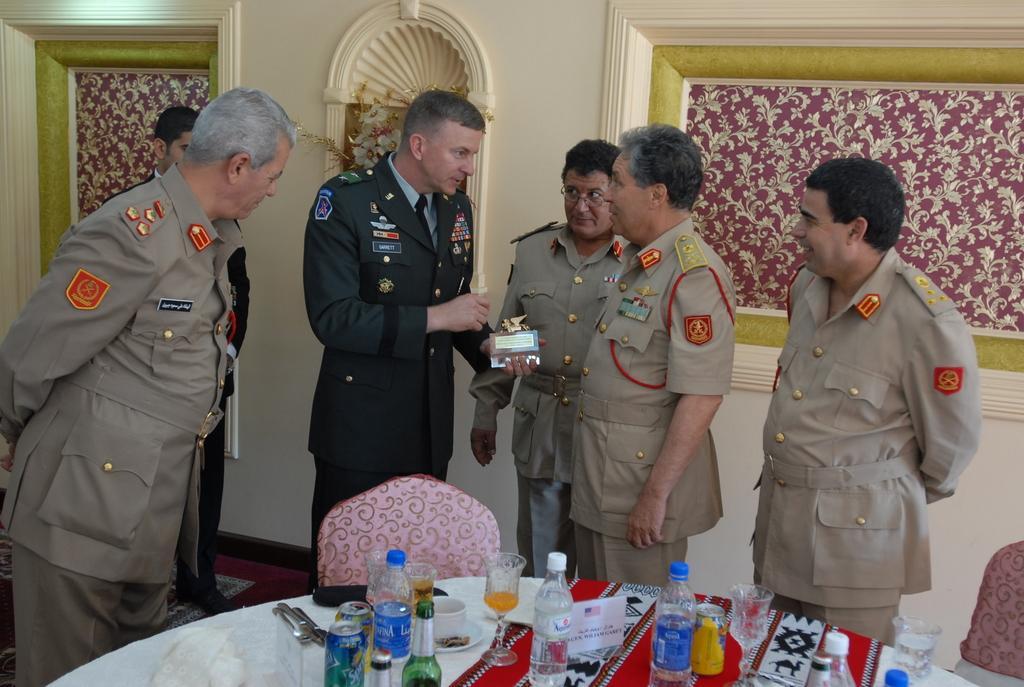In one or two sentences, can you explain what this image depicts? In this picture there are people in the center of the image, it seems to be they are cops and there is a dining table at the bottom side of the image, on which there are glasses and bottles are placed, there is a decorated wall in the background area of the image. 